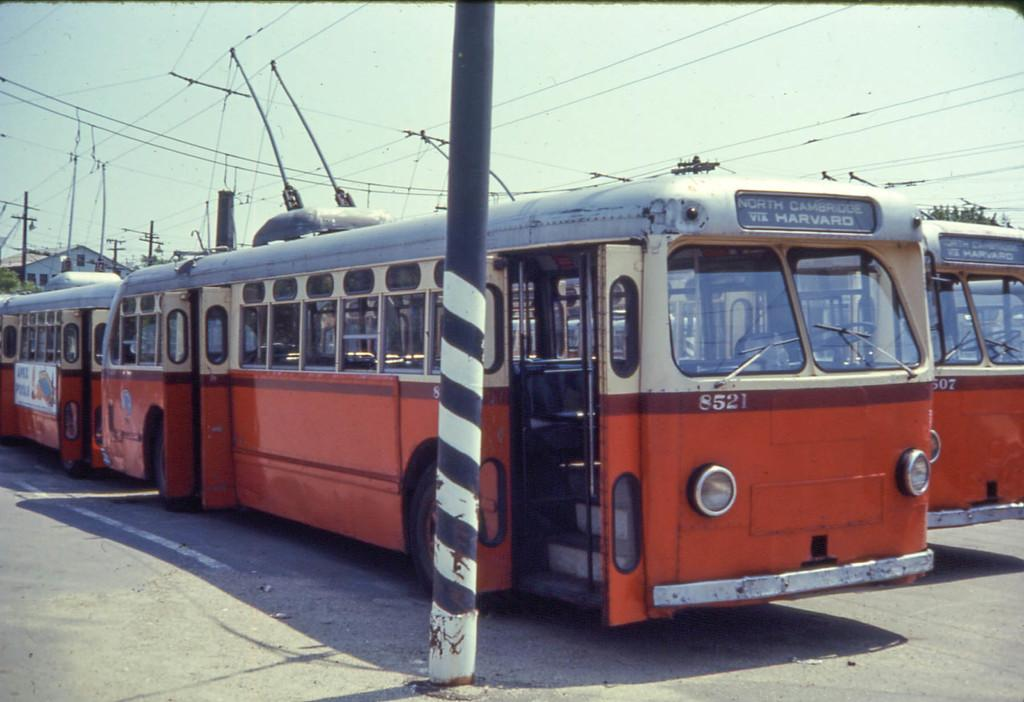What types of objects can be seen in the image? There are vehicles and poles in the image. What is present at the top of the image? There are wires and the sky visible at the top of the image. What can be seen in the background of the image? There is a shed and trees in the background of the image. What type of substance is being attacked by the pet in the image? There is no pet or substance being attacked in the image. 